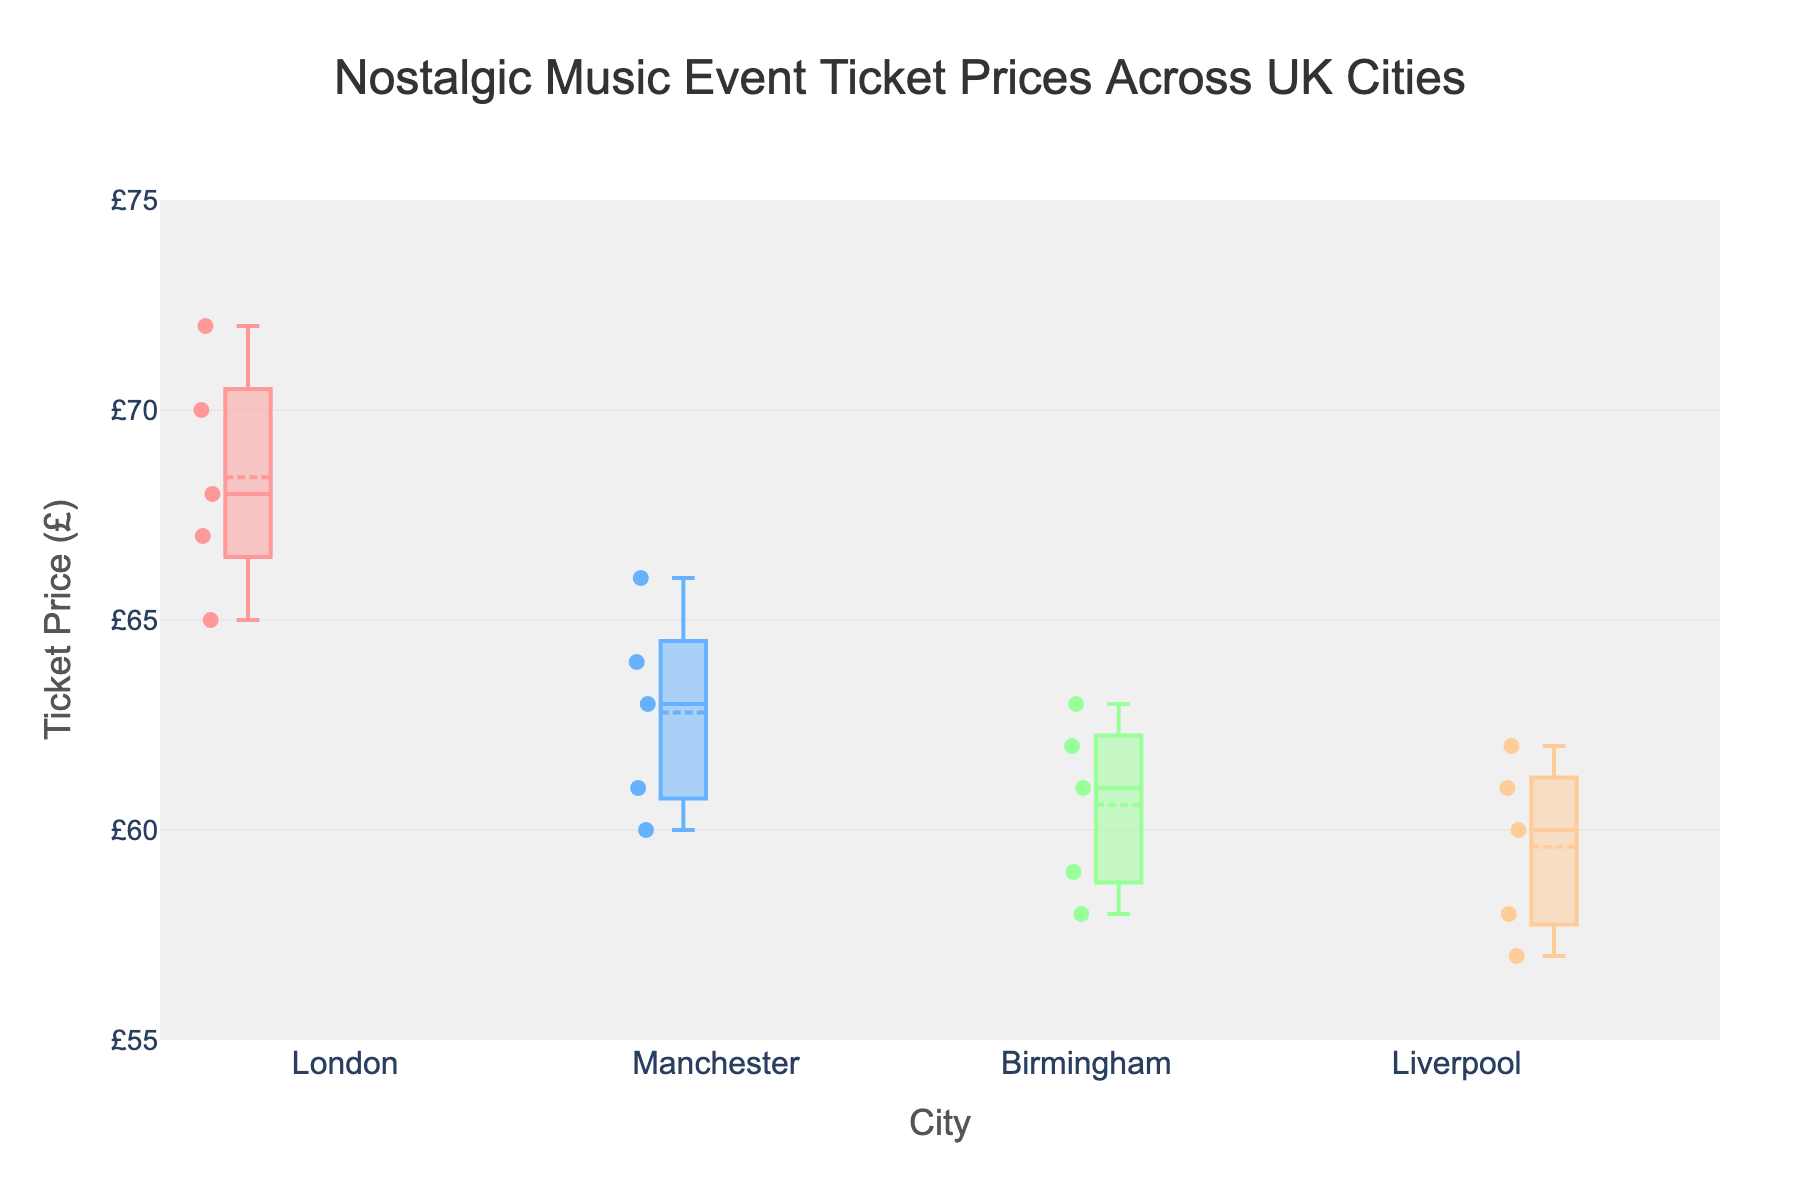What's the title of the figure? The title is typically found at the top of the figure and it provides a summary of what the plot represents. In this case, the title is indicated in the code provided.
Answer: Nostalgic Music Event Ticket Prices Across UK Cities Which city has the highest median ticket price? The median ticket price for each city can be identified by the line inside each box in the plot. The city with the highest median will have this line positioned higher on the price axis than others.
Answer: London What is the approximate range of ticket prices in Birmingham? The range of ticket prices can be determined by looking at the bottom (minimum) and top (maximum) lines of the box plot for Birmingham. The data range for each city is indicated by these lines.
Answer: £58 - £63 How does the spread of ticket prices in Liverpool compare to that in Manchester? The spread or variability of ticket prices within a city is illustrated by the length of the box in the plot. Liverpool's box appears wider compared to Manchester's, indicating a larger spread.
Answer: Liverpool has a larger spread than Manchester What's the average ticket price across all cities? To find the average ticket price, you would need to calculate the means for each city and then average these values. Each box plot indicates the mean with a specific marker. Sum these means and divide by the number of cities. This involves several steps: first adding the means, then dividing by the number of cities (4 in this case).
Answer: £63.5 Which city has the least variation in ticket prices? The city with the least variation will have the smallest interquartile range, indicated by the height of the box being the smallest compared to others.
Answer: Birmingham Does London have any outliers in ticket prices? Outliers are shown as distinct points away from the main range of data in a box plot. By examining the box plot for London, you can check if there are any such points.
Answer: No What is the ticket price range for the "Time Warp Tunes" event across all cities? To determine this, look at the specific points for "Time Warp Tunes" in each city's distribution. The highest value is in London (£67) and the lowest is in Liverpool (£61).
Answer: £61 - £67 How does the ticket price for "Retro Beats" compare between London and Birmingham? You would compare the specific data points for "Retro Beats" in the box plots for London and Birmingham. In London, the ticket price is £68, and in Birmingham, it's £59.
Answer: London is £9 more than Birmingham 